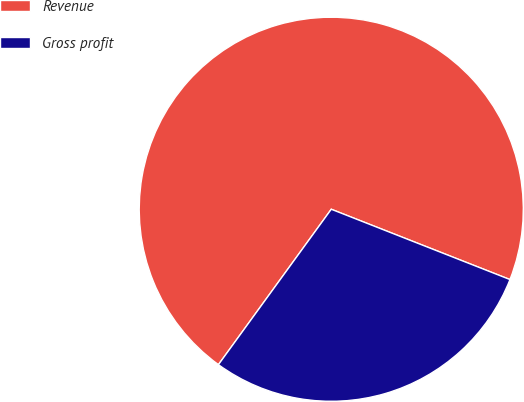Convert chart to OTSL. <chart><loc_0><loc_0><loc_500><loc_500><pie_chart><fcel>Revenue<fcel>Gross profit<nl><fcel>70.97%<fcel>29.03%<nl></chart> 